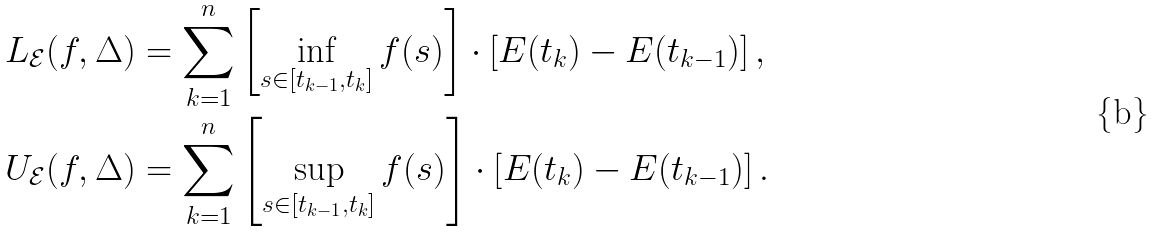Convert formula to latex. <formula><loc_0><loc_0><loc_500><loc_500>L _ { \mathcal { E } } ( f , \Delta ) & = \sum _ { k = 1 } ^ { n } \left [ \inf _ { s \in [ t _ { k - 1 } , t _ { k } ] } f ( s ) \right ] \cdot \left [ E ( t _ { k } ) - E ( t _ { k - 1 } ) \right ] , \\ U _ { \mathcal { E } } ( f , \Delta ) & = \sum _ { k = 1 } ^ { n } \left [ \sup _ { s \in [ t _ { k - 1 } , t _ { k } ] } f ( s ) \right ] \cdot \left [ E ( t _ { k } ) - E ( t _ { k - 1 } ) \right ] .</formula> 